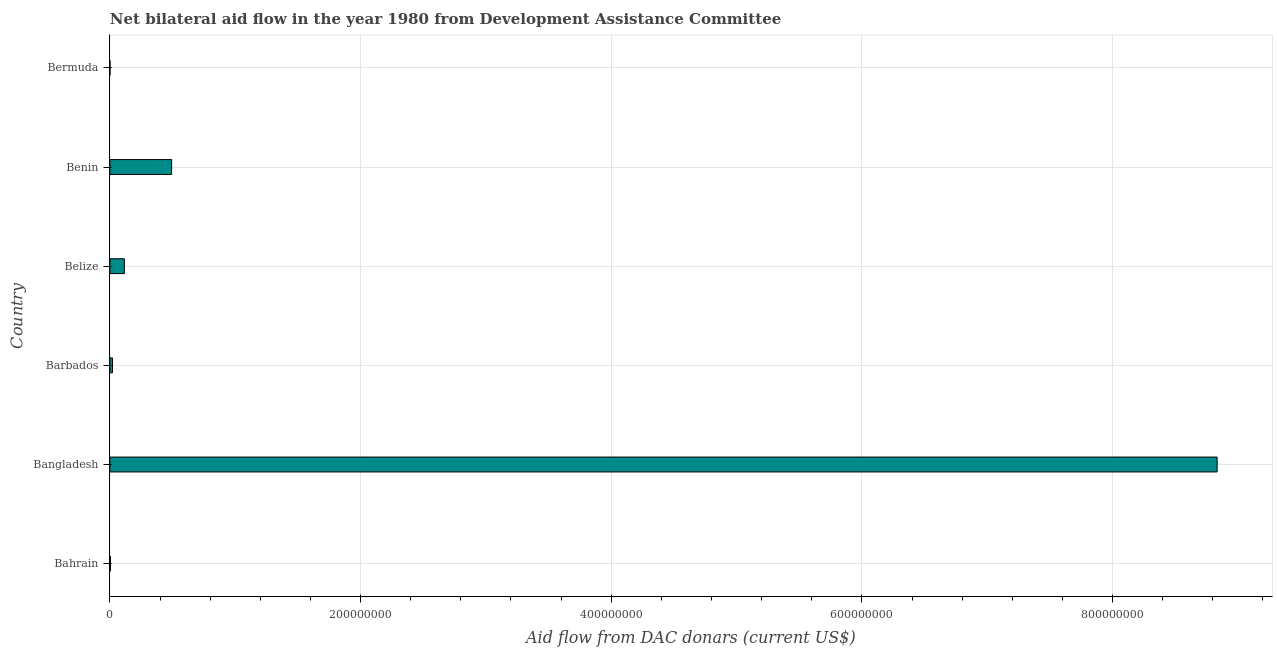Does the graph contain any zero values?
Provide a succinct answer. No. Does the graph contain grids?
Ensure brevity in your answer.  Yes. What is the title of the graph?
Keep it short and to the point. Net bilateral aid flow in the year 1980 from Development Assistance Committee. What is the label or title of the X-axis?
Make the answer very short. Aid flow from DAC donars (current US$). Across all countries, what is the maximum net bilateral aid flows from dac donors?
Your response must be concise. 8.83e+08. In which country was the net bilateral aid flows from dac donors minimum?
Give a very brief answer. Bermuda. What is the sum of the net bilateral aid flows from dac donors?
Provide a succinct answer. 9.47e+08. What is the difference between the net bilateral aid flows from dac donors in Bangladesh and Barbados?
Make the answer very short. 8.81e+08. What is the average net bilateral aid flows from dac donors per country?
Your response must be concise. 1.58e+08. What is the median net bilateral aid flows from dac donors?
Give a very brief answer. 6.83e+06. In how many countries, is the net bilateral aid flows from dac donors greater than 360000000 US$?
Your response must be concise. 1. What is the ratio of the net bilateral aid flows from dac donors in Bahrain to that in Barbados?
Offer a terse response. 0.2. Is the difference between the net bilateral aid flows from dac donors in Bahrain and Bermuda greater than the difference between any two countries?
Your response must be concise. No. What is the difference between the highest and the second highest net bilateral aid flows from dac donors?
Offer a very short reply. 8.34e+08. What is the difference between the highest and the lowest net bilateral aid flows from dac donors?
Provide a succinct answer. 8.83e+08. In how many countries, is the net bilateral aid flows from dac donors greater than the average net bilateral aid flows from dac donors taken over all countries?
Provide a short and direct response. 1. How many bars are there?
Your answer should be very brief. 6. Are the values on the major ticks of X-axis written in scientific E-notation?
Your response must be concise. No. What is the Aid flow from DAC donars (current US$) of Bangladesh?
Your answer should be very brief. 8.83e+08. What is the Aid flow from DAC donars (current US$) of Barbados?
Your answer should be very brief. 2.10e+06. What is the Aid flow from DAC donars (current US$) in Belize?
Your answer should be very brief. 1.16e+07. What is the Aid flow from DAC donars (current US$) in Benin?
Offer a terse response. 4.93e+07. What is the Aid flow from DAC donars (current US$) in Bermuda?
Offer a very short reply. 6.00e+04. What is the difference between the Aid flow from DAC donars (current US$) in Bahrain and Bangladesh?
Make the answer very short. -8.83e+08. What is the difference between the Aid flow from DAC donars (current US$) in Bahrain and Barbados?
Offer a terse response. -1.67e+06. What is the difference between the Aid flow from DAC donars (current US$) in Bahrain and Belize?
Your answer should be compact. -1.11e+07. What is the difference between the Aid flow from DAC donars (current US$) in Bahrain and Benin?
Keep it short and to the point. -4.88e+07. What is the difference between the Aid flow from DAC donars (current US$) in Bahrain and Bermuda?
Provide a short and direct response. 3.70e+05. What is the difference between the Aid flow from DAC donars (current US$) in Bangladesh and Barbados?
Offer a very short reply. 8.81e+08. What is the difference between the Aid flow from DAC donars (current US$) in Bangladesh and Belize?
Provide a succinct answer. 8.72e+08. What is the difference between the Aid flow from DAC donars (current US$) in Bangladesh and Benin?
Offer a terse response. 8.34e+08. What is the difference between the Aid flow from DAC donars (current US$) in Bangladesh and Bermuda?
Offer a very short reply. 8.83e+08. What is the difference between the Aid flow from DAC donars (current US$) in Barbados and Belize?
Your response must be concise. -9.46e+06. What is the difference between the Aid flow from DAC donars (current US$) in Barbados and Benin?
Provide a short and direct response. -4.72e+07. What is the difference between the Aid flow from DAC donars (current US$) in Barbados and Bermuda?
Your answer should be very brief. 2.04e+06. What is the difference between the Aid flow from DAC donars (current US$) in Belize and Benin?
Ensure brevity in your answer.  -3.77e+07. What is the difference between the Aid flow from DAC donars (current US$) in Belize and Bermuda?
Offer a terse response. 1.15e+07. What is the difference between the Aid flow from DAC donars (current US$) in Benin and Bermuda?
Give a very brief answer. 4.92e+07. What is the ratio of the Aid flow from DAC donars (current US$) in Bahrain to that in Barbados?
Keep it short and to the point. 0.2. What is the ratio of the Aid flow from DAC donars (current US$) in Bahrain to that in Belize?
Offer a terse response. 0.04. What is the ratio of the Aid flow from DAC donars (current US$) in Bahrain to that in Benin?
Keep it short and to the point. 0.01. What is the ratio of the Aid flow from DAC donars (current US$) in Bahrain to that in Bermuda?
Keep it short and to the point. 7.17. What is the ratio of the Aid flow from DAC donars (current US$) in Bangladesh to that in Barbados?
Give a very brief answer. 420.69. What is the ratio of the Aid flow from DAC donars (current US$) in Bangladesh to that in Belize?
Give a very brief answer. 76.42. What is the ratio of the Aid flow from DAC donars (current US$) in Bangladesh to that in Benin?
Provide a succinct answer. 17.93. What is the ratio of the Aid flow from DAC donars (current US$) in Bangladesh to that in Bermuda?
Ensure brevity in your answer.  1.47e+04. What is the ratio of the Aid flow from DAC donars (current US$) in Barbados to that in Belize?
Provide a short and direct response. 0.18. What is the ratio of the Aid flow from DAC donars (current US$) in Barbados to that in Benin?
Provide a succinct answer. 0.04. What is the ratio of the Aid flow from DAC donars (current US$) in Barbados to that in Bermuda?
Ensure brevity in your answer.  35. What is the ratio of the Aid flow from DAC donars (current US$) in Belize to that in Benin?
Your answer should be very brief. 0.23. What is the ratio of the Aid flow from DAC donars (current US$) in Belize to that in Bermuda?
Offer a terse response. 192.67. What is the ratio of the Aid flow from DAC donars (current US$) in Benin to that in Bermuda?
Your answer should be very brief. 821.17. 